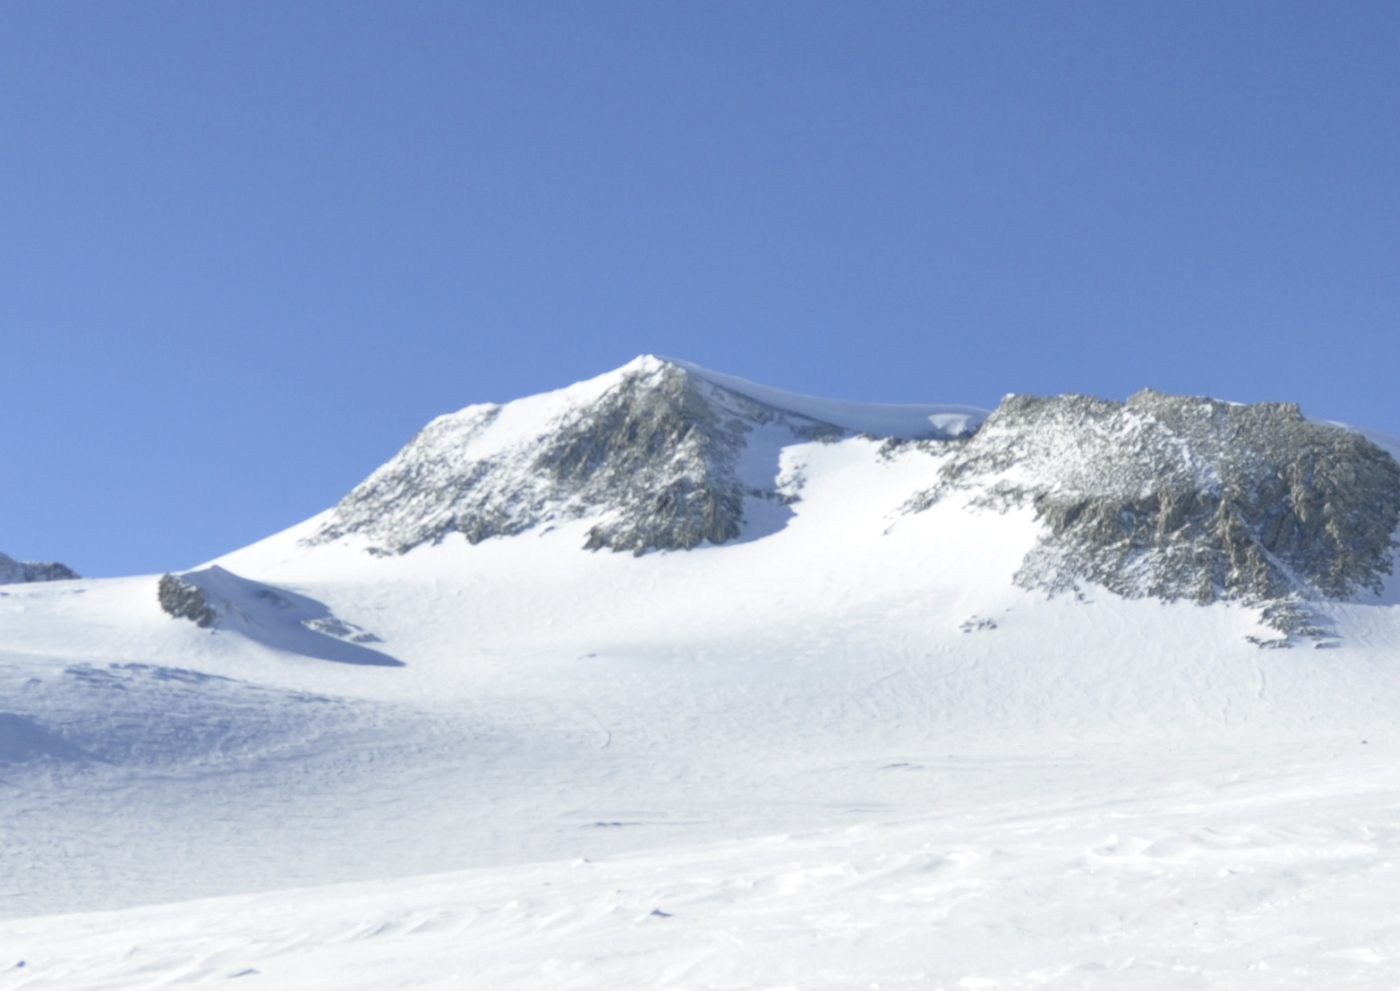Could this location be used for any scientific research, and if so, what kind? Yes, Vinson Massif and its surrounding regions in Antarctica are prime locations for a variety of scientific research. Climatologists study the ice cores drilled from the glaciers to understand the Earth’s past climate, gathering data that spans hundreds of thousands of years. Glaciologists examine the dynamics of the ice flows and how they are affected by climate change. Biologists may focus on extremophiles, microorganisms that thrive in extreme cold, to gain insights into the resilience of life. Additionally, geologists can study the unique rock formations and tectonic history revealed by the exposed peaks and cliffs. This research is crucial for understanding global climate patterns, ice-sheet stability, and biological adaptation in extreme environments. 